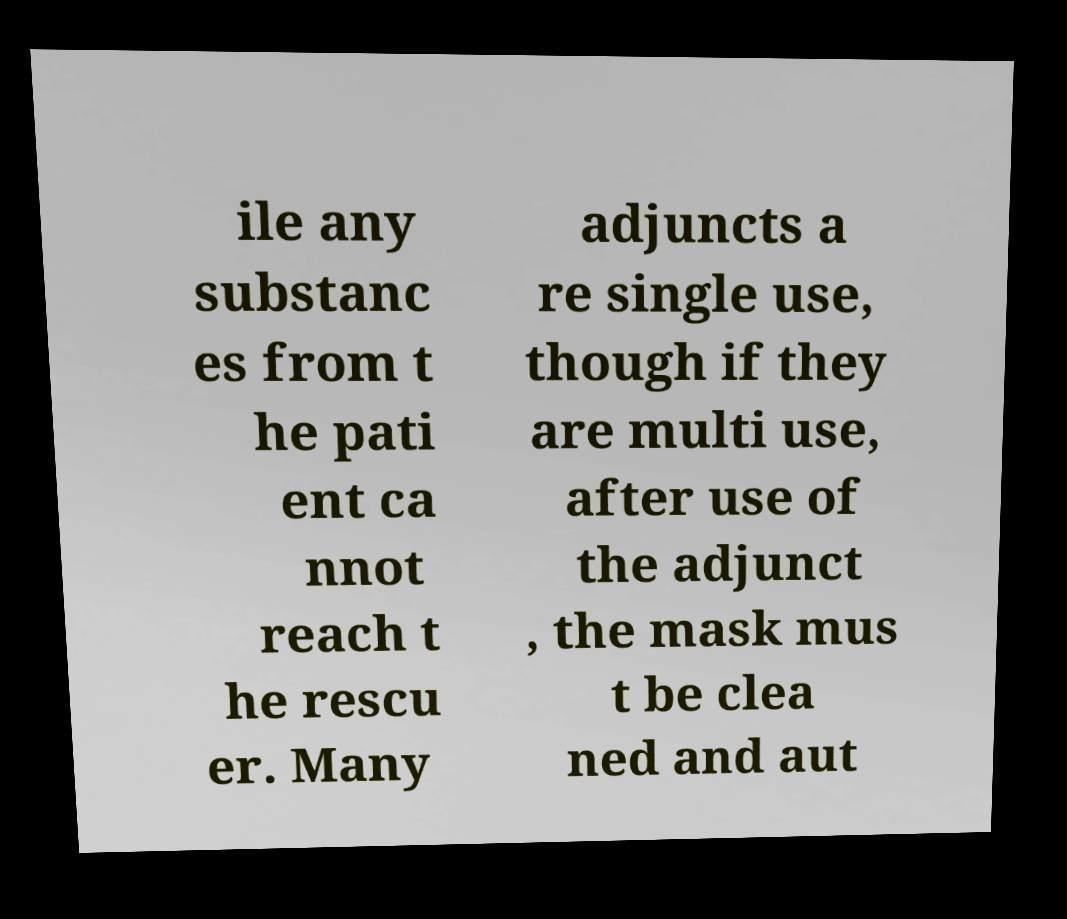Can you accurately transcribe the text from the provided image for me? ile any substanc es from t he pati ent ca nnot reach t he rescu er. Many adjuncts a re single use, though if they are multi use, after use of the adjunct , the mask mus t be clea ned and aut 